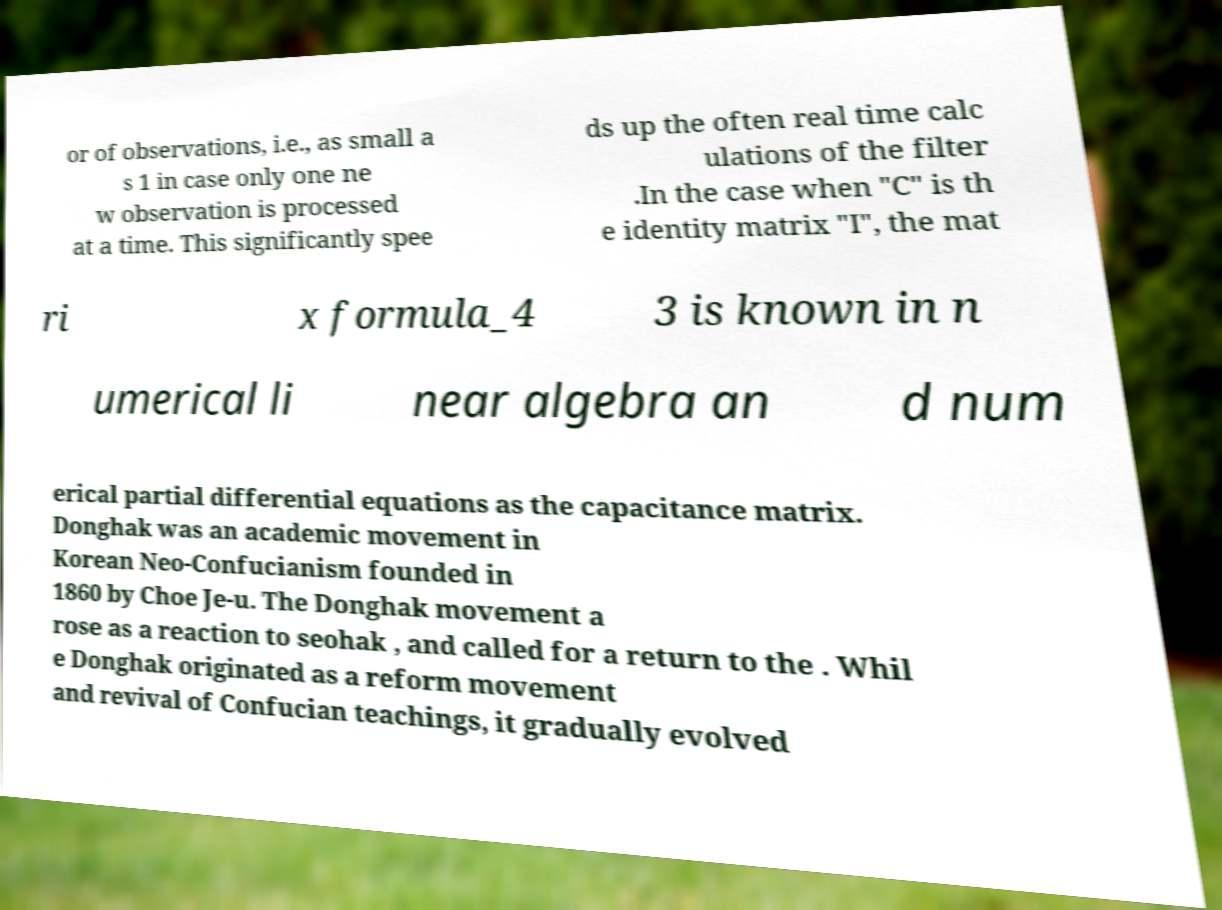Can you read and provide the text displayed in the image?This photo seems to have some interesting text. Can you extract and type it out for me? or of observations, i.e., as small a s 1 in case only one ne w observation is processed at a time. This significantly spee ds up the often real time calc ulations of the filter .In the case when "C" is th e identity matrix "I", the mat ri x formula_4 3 is known in n umerical li near algebra an d num erical partial differential equations as the capacitance matrix. Donghak was an academic movement in Korean Neo-Confucianism founded in 1860 by Choe Je-u. The Donghak movement a rose as a reaction to seohak , and called for a return to the . Whil e Donghak originated as a reform movement and revival of Confucian teachings, it gradually evolved 